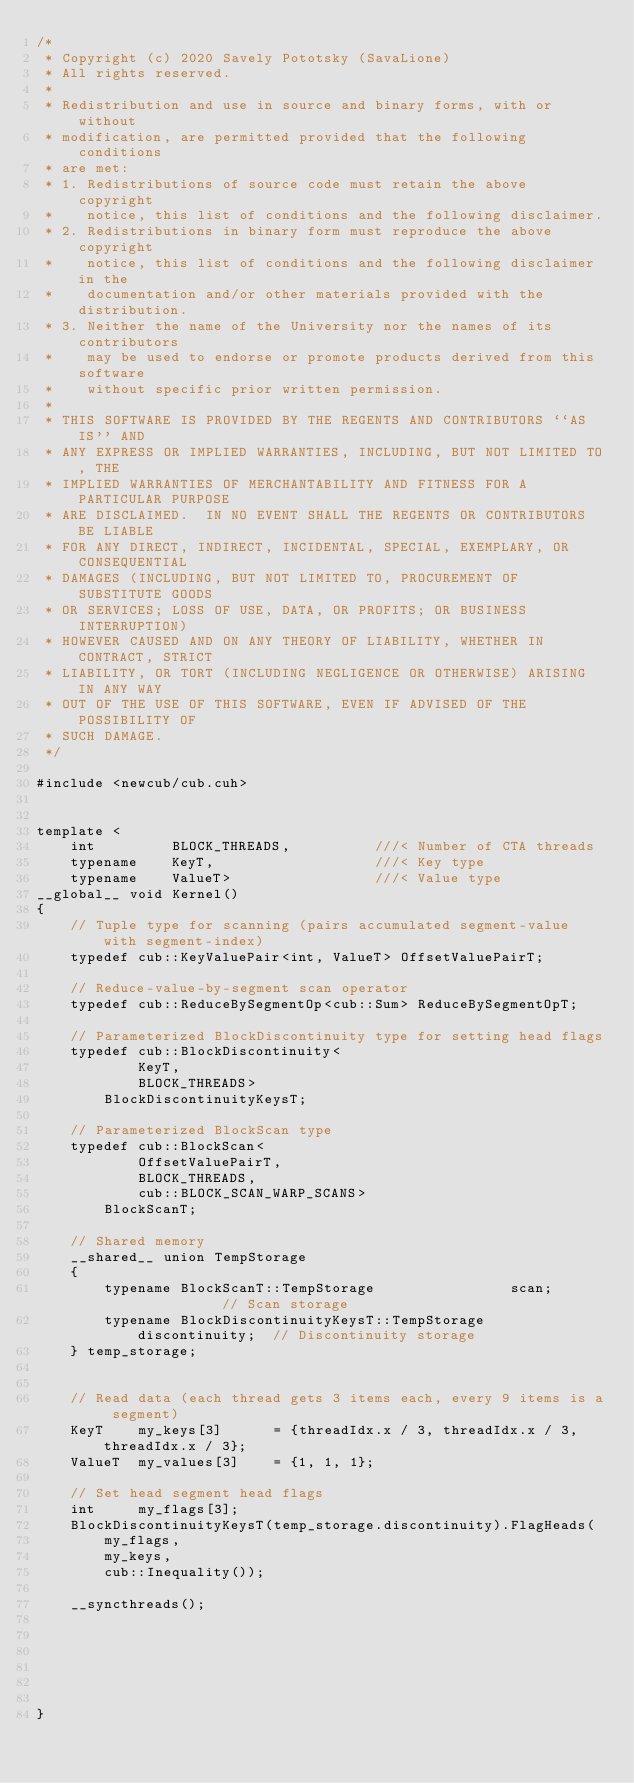Convert code to text. <code><loc_0><loc_0><loc_500><loc_500><_Cuda_>/*
 * Copyright (c) 2020 Savely Pototsky (SavaLione)
 * All rights reserved.
 *
 * Redistribution and use in source and binary forms, with or without
 * modification, are permitted provided that the following conditions
 * are met:
 * 1. Redistributions of source code must retain the above copyright
 *    notice, this list of conditions and the following disclaimer.
 * 2. Redistributions in binary form must reproduce the above copyright
 *    notice, this list of conditions and the following disclaimer in the
 *    documentation and/or other materials provided with the distribution.
 * 3. Neither the name of the University nor the names of its contributors
 *    may be used to endorse or promote products derived from this software
 *    without specific prior written permission.
 *
 * THIS SOFTWARE IS PROVIDED BY THE REGENTS AND CONTRIBUTORS ``AS IS'' AND
 * ANY EXPRESS OR IMPLIED WARRANTIES, INCLUDING, BUT NOT LIMITED TO, THE
 * IMPLIED WARRANTIES OF MERCHANTABILITY AND FITNESS FOR A PARTICULAR PURPOSE
 * ARE DISCLAIMED.  IN NO EVENT SHALL THE REGENTS OR CONTRIBUTORS BE LIABLE
 * FOR ANY DIRECT, INDIRECT, INCIDENTAL, SPECIAL, EXEMPLARY, OR CONSEQUENTIAL
 * DAMAGES (INCLUDING, BUT NOT LIMITED TO, PROCUREMENT OF SUBSTITUTE GOODS
 * OR SERVICES; LOSS OF USE, DATA, OR PROFITS; OR BUSINESS INTERRUPTION)
 * HOWEVER CAUSED AND ON ANY THEORY OF LIABILITY, WHETHER IN CONTRACT, STRICT
 * LIABILITY, OR TORT (INCLUDING NEGLIGENCE OR OTHERWISE) ARISING IN ANY WAY
 * OUT OF THE USE OF THIS SOFTWARE, EVEN IF ADVISED OF THE POSSIBILITY OF
 * SUCH DAMAGE.
 */

#include <newcub/cub.cuh>


template <
    int         BLOCK_THREADS,          ///< Number of CTA threads
    typename    KeyT,                   ///< Key type
    typename    ValueT>                 ///< Value type
__global__ void Kernel()
{
    // Tuple type for scanning (pairs accumulated segment-value with segment-index)
    typedef cub::KeyValuePair<int, ValueT> OffsetValuePairT;

    // Reduce-value-by-segment scan operator
    typedef cub::ReduceBySegmentOp<cub::Sum> ReduceBySegmentOpT;

    // Parameterized BlockDiscontinuity type for setting head flags
    typedef cub::BlockDiscontinuity<
            KeyT,
            BLOCK_THREADS>
        BlockDiscontinuityKeysT;

    // Parameterized BlockScan type
    typedef cub::BlockScan<
            OffsetValuePairT,
            BLOCK_THREADS,
            cub::BLOCK_SCAN_WARP_SCANS>
        BlockScanT;

    // Shared memory
    __shared__ union TempStorage
    {
        typename BlockScanT::TempStorage                scan;           // Scan storage
        typename BlockDiscontinuityKeysT::TempStorage   discontinuity;  // Discontinuity storage
    } temp_storage;


    // Read data (each thread gets 3 items each, every 9 items is a segment)
    KeyT    my_keys[3]      = {threadIdx.x / 3, threadIdx.x / 3, threadIdx.x / 3};
    ValueT  my_values[3]    = {1, 1, 1};

    // Set head segment head flags
    int     my_flags[3];
    BlockDiscontinuityKeysT(temp_storage.discontinuity).FlagHeads(
        my_flags,
        my_keys,
        cub::Inequality());

    __syncthreads();






}
</code> 